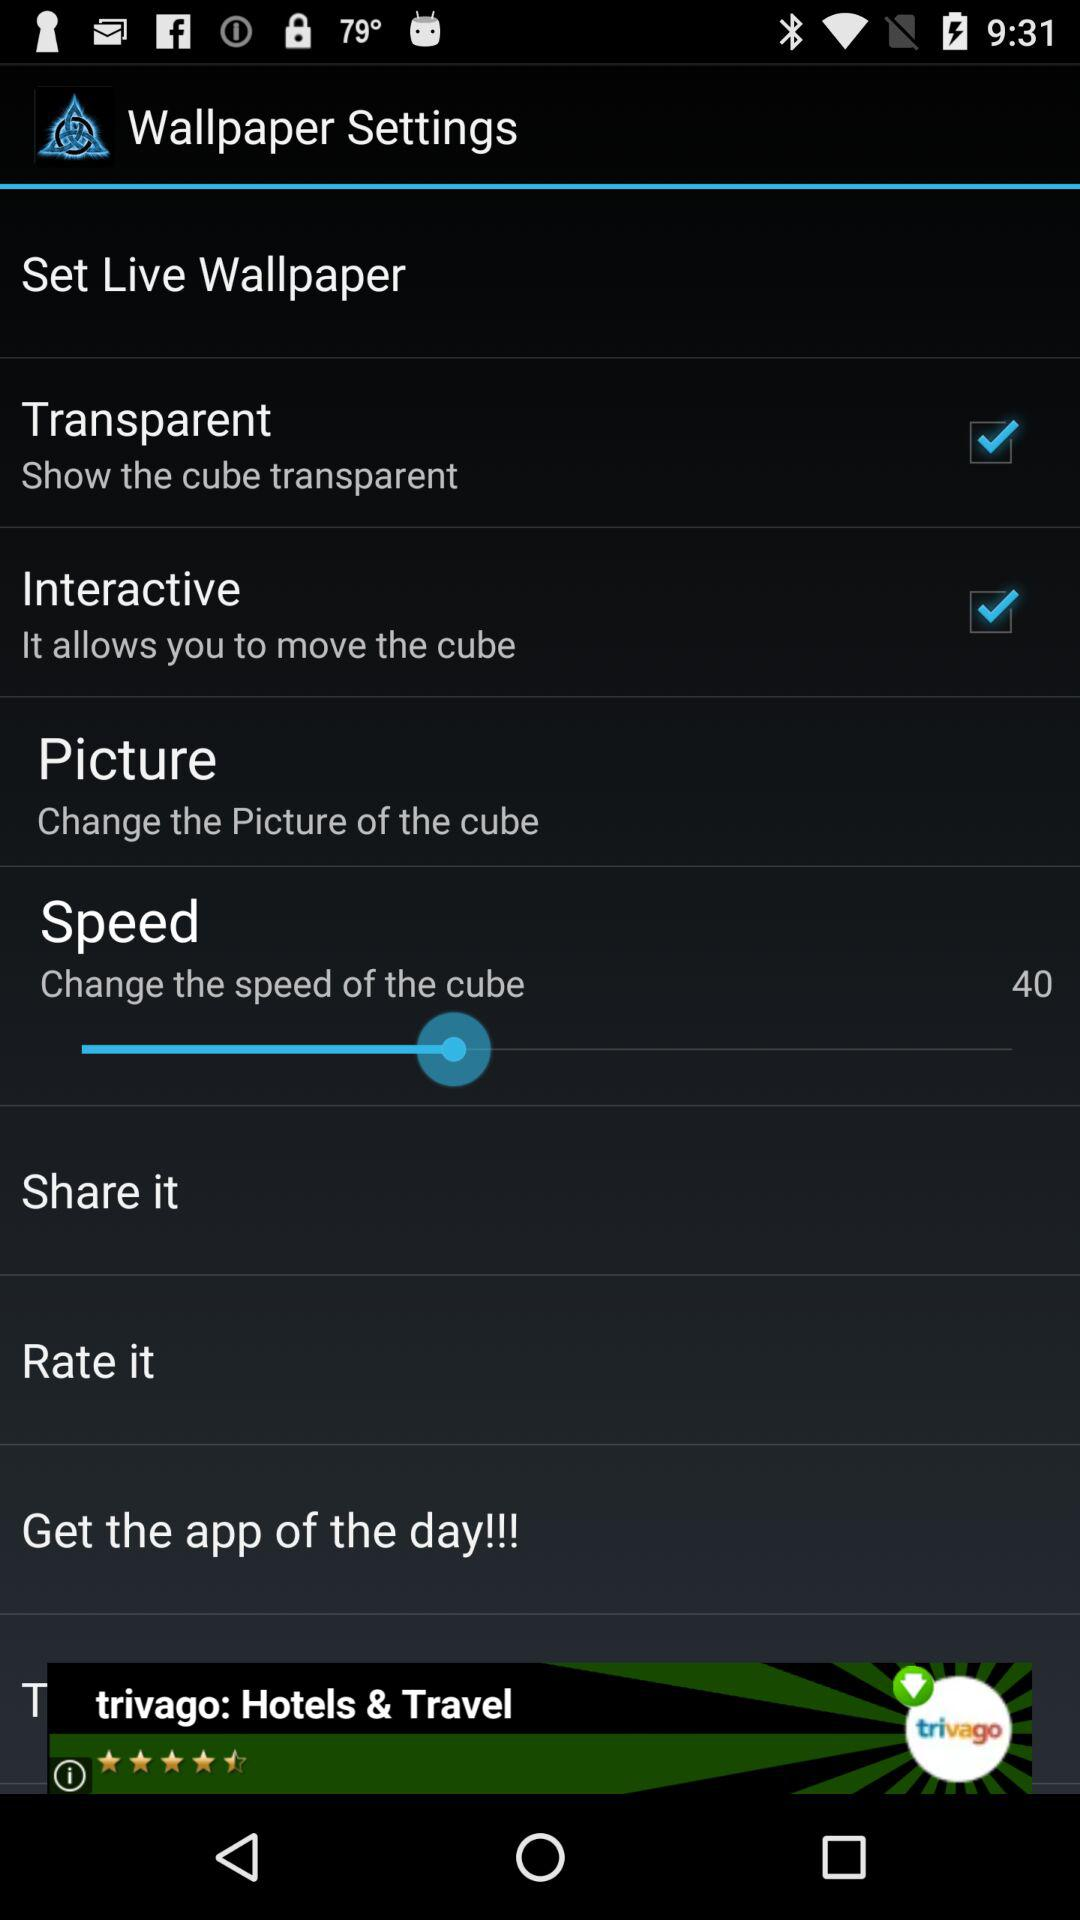What is the value of speed? The value of speed is 40. 